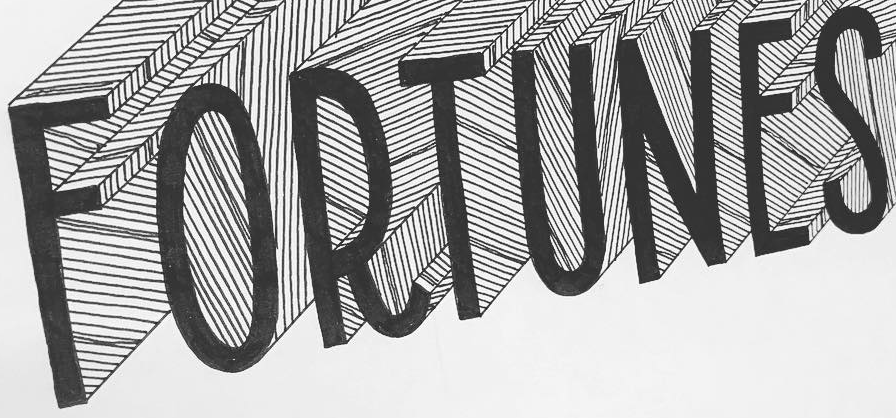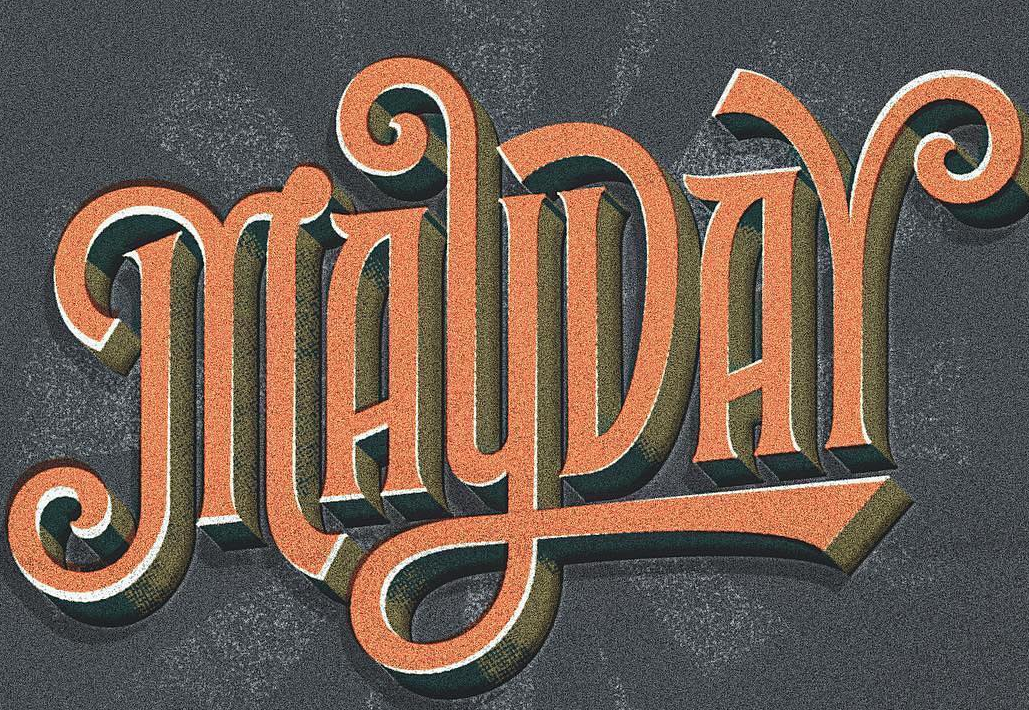What text appears in these images from left to right, separated by a semicolon? FORTUNES; MAYDAY 